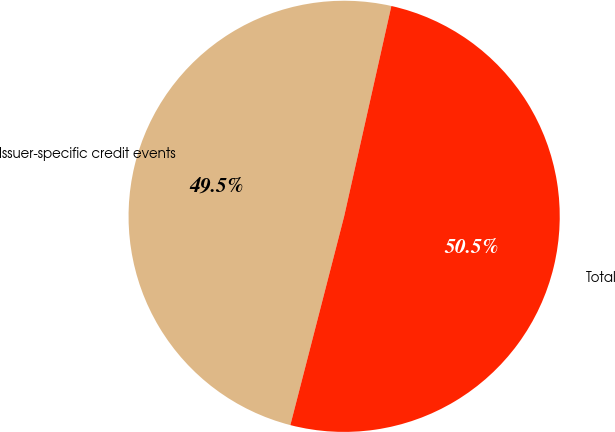<chart> <loc_0><loc_0><loc_500><loc_500><pie_chart><fcel>Issuer-specific credit events<fcel>Total<nl><fcel>49.5%<fcel>50.5%<nl></chart> 